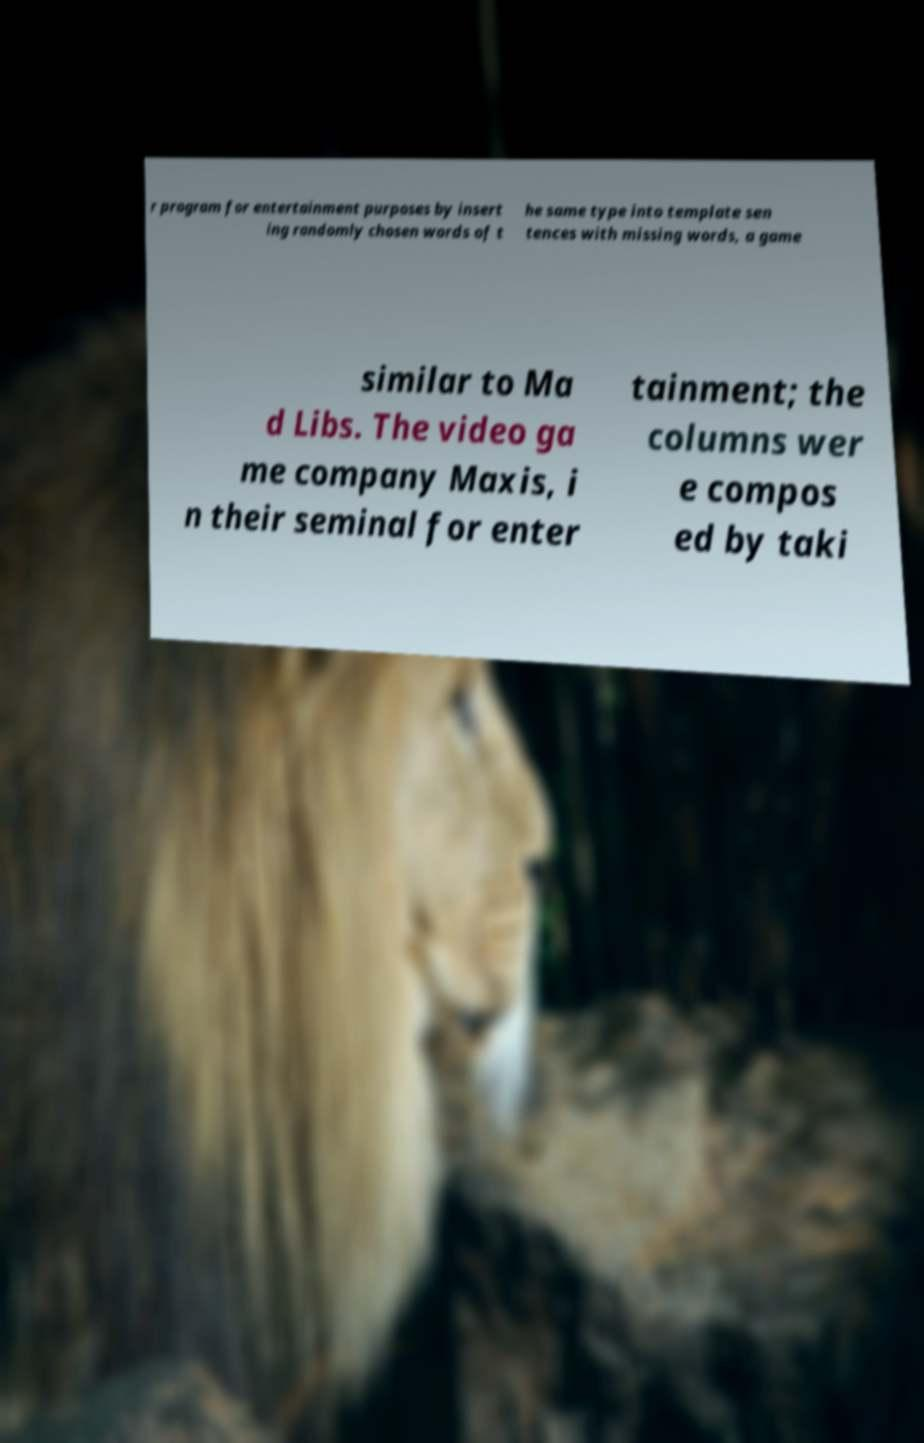For documentation purposes, I need the text within this image transcribed. Could you provide that? r program for entertainment purposes by insert ing randomly chosen words of t he same type into template sen tences with missing words, a game similar to Ma d Libs. The video ga me company Maxis, i n their seminal for enter tainment; the columns wer e compos ed by taki 